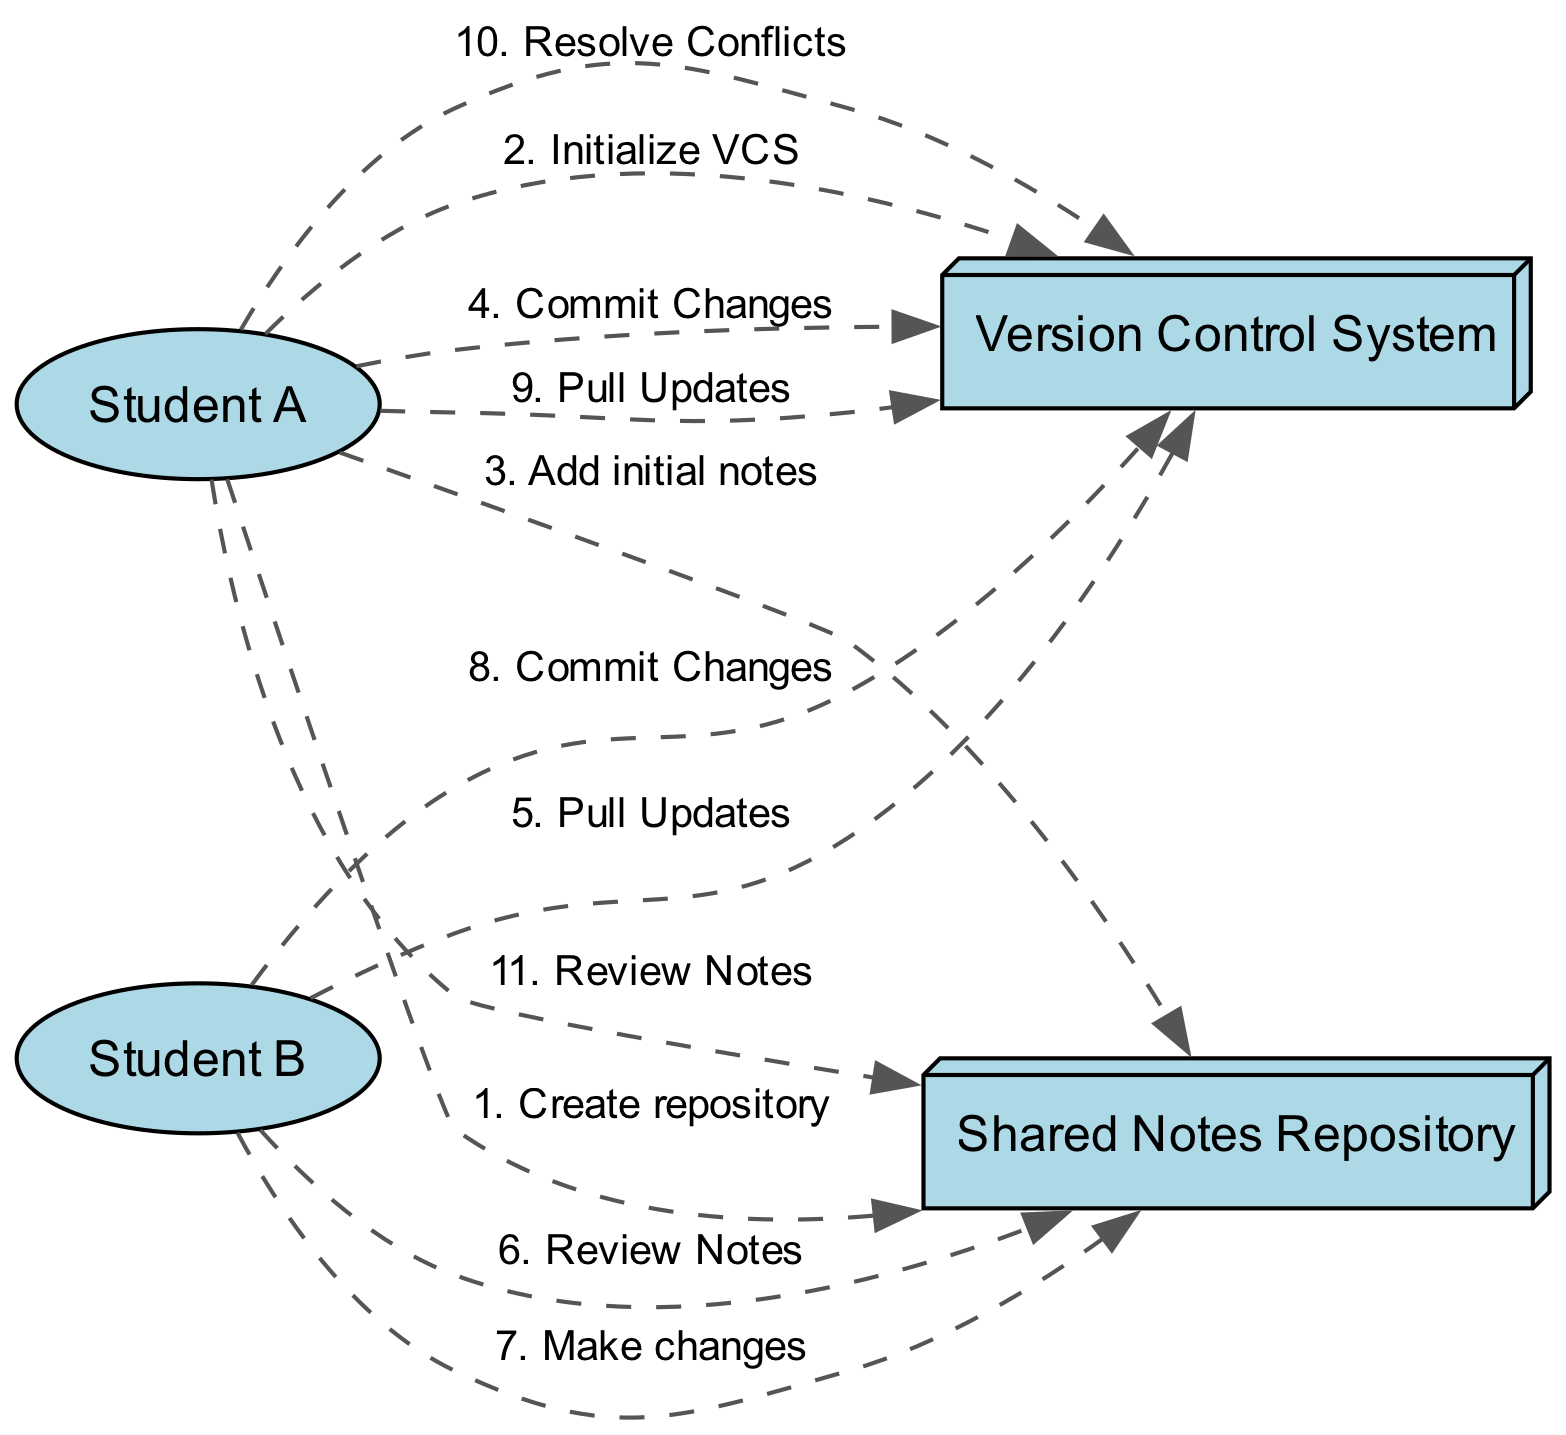What are the two actors in the diagram? The diagram includes two actors: "Student A" and "Student B." These are explicitly listed in the elements of the data provided.
Answer: Student A, Student B How many actions are represented in the diagram? The diagram outlines a sequence of actions, which include creating a repository, initializing the VCS, adding notes, committing changes, pulling updates, reviewing notes, making changes, and resolving conflicts. Counting these actions gives a total of eleven actions.
Answer: Eleven Who creates the notes repository? The action of creating the repository is attributed to "Student A," as indicated by the first action listed in the sequence of actions.
Answer: Student A What does Student B do after pulling updates? Following the action of pulling updates, "Student B" reviews the shared notes, as specified in the sequence of actions of the diagram.
Answer: Review Notes How many commits are made in total? There are two commit actions in the sequence: one by "Student A" and one by "Student B." This totals to two commit actions.
Answer: Two Which system does "Student A" interact with first? "Student A" first interacts with the "Shared Notes Repository" to create the repository, as seen in the first action of the sequence.
Answer: Shared Notes Repository Who resolves conflicts, and at what stage does this occur? "Student A" resolves conflicts after pulling updates, as indicated in the sequence of actions. This occurs in the flow right after "Student A" pulls updates following "Student B's" changes.
Answer: Student A What is the order of actions involving the Version Control System? The actions involving the Version Control System in order are: initialize VCS, commit changes by Student A, pull updates by Student B, commit changes by Student B, pull updates by Student A, resolve conflicts. The sequence of events results in six interactions with the VCS.
Answer: Six What does "Student B" do after reviewing notes? After reviewing the notes, "Student B" makes changes to the shared notes, as described in the sequence of actions.
Answer: Make changes 